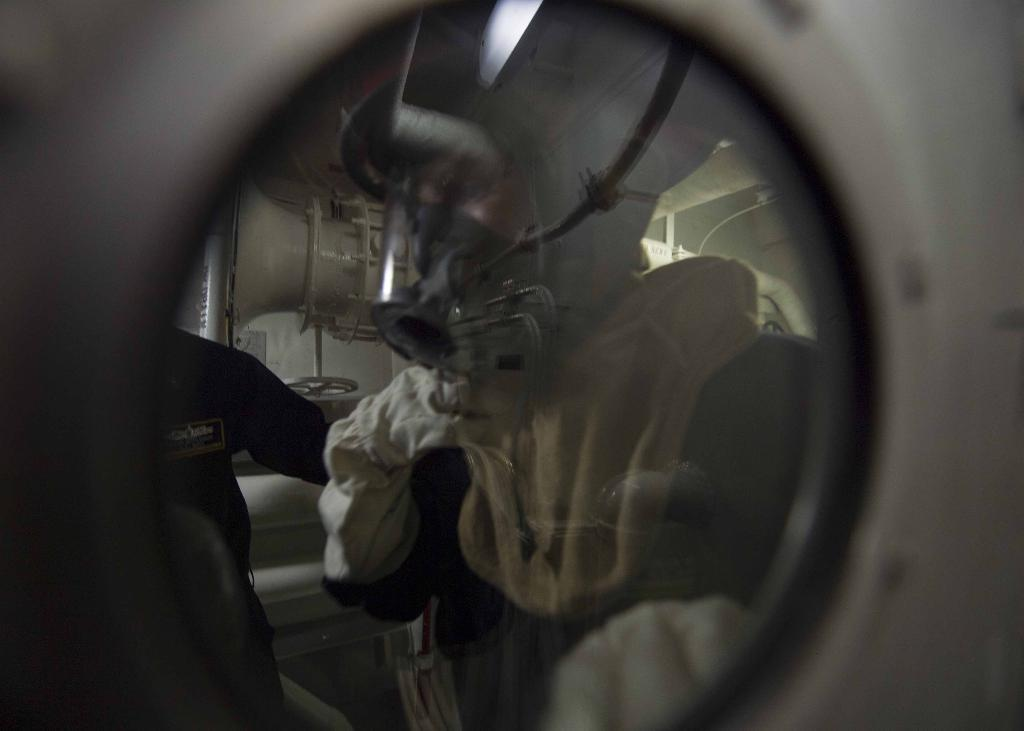What is present in the image that can be used to hold liquids? There is a glass in the image. What can be seen through the glass? A person, clothes, and other objects are visible through the glass. Can you describe the person visible through the glass? The provided facts do not give enough information to describe the person. What type of shoes is the person talking about in the image? There is no person talking about shoes in the image, as the provided facts do not mention any conversation or shoes. 